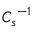Convert formula to latex. <formula><loc_0><loc_0><loc_500><loc_500>{ C _ { s } } ^ { - 1 }</formula> 